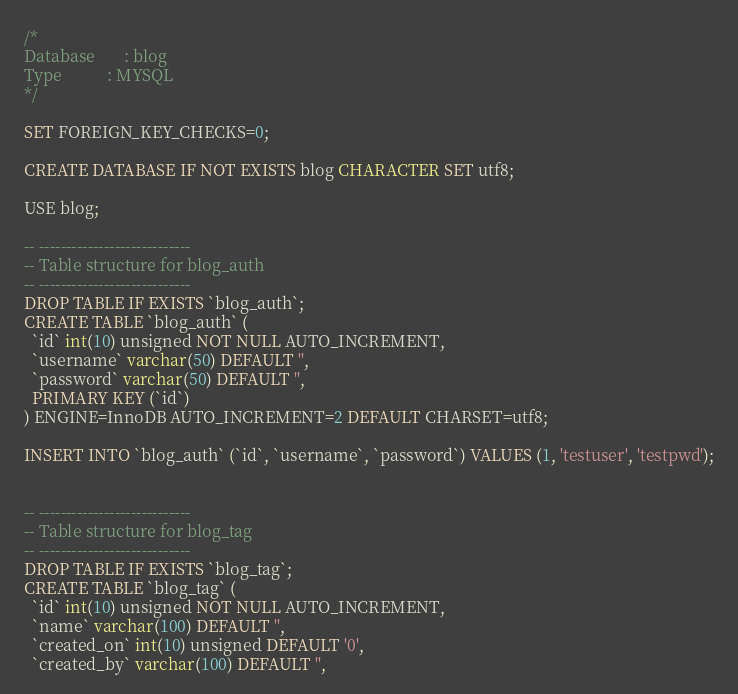Convert code to text. <code><loc_0><loc_0><loc_500><loc_500><_SQL_>/*
Database       : blog
Type           : MYSQL
*/

SET FOREIGN_KEY_CHECKS=0;

CREATE DATABASE IF NOT EXISTS blog CHARACTER SET utf8;

USE blog;

-- ----------------------------
-- Table structure for blog_auth
-- ----------------------------
DROP TABLE IF EXISTS `blog_auth`;
CREATE TABLE `blog_auth` (
  `id` int(10) unsigned NOT NULL AUTO_INCREMENT,
  `username` varchar(50) DEFAULT '',
  `password` varchar(50) DEFAULT '',
  PRIMARY KEY (`id`)
) ENGINE=InnoDB AUTO_INCREMENT=2 DEFAULT CHARSET=utf8;

INSERT INTO `blog_auth` (`id`, `username`, `password`) VALUES (1, 'testuser', 'testpwd');


-- ----------------------------
-- Table structure for blog_tag
-- ----------------------------
DROP TABLE IF EXISTS `blog_tag`;
CREATE TABLE `blog_tag` (
  `id` int(10) unsigned NOT NULL AUTO_INCREMENT,
  `name` varchar(100) DEFAULT '',
  `created_on` int(10) unsigned DEFAULT '0',
  `created_by` varchar(100) DEFAULT '',</code> 